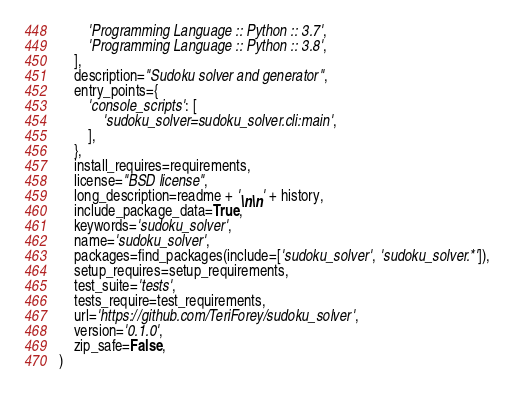<code> <loc_0><loc_0><loc_500><loc_500><_Python_>        'Programming Language :: Python :: 3.7',
        'Programming Language :: Python :: 3.8',
    ],
    description="Sudoku solver and generator",
    entry_points={
        'console_scripts': [
            'sudoku_solver=sudoku_solver.cli:main',
        ],
    },
    install_requires=requirements,
    license="BSD license",
    long_description=readme + '\n\n' + history,
    include_package_data=True,
    keywords='sudoku_solver',
    name='sudoku_solver',
    packages=find_packages(include=['sudoku_solver', 'sudoku_solver.*']),
    setup_requires=setup_requirements,
    test_suite='tests',
    tests_require=test_requirements,
    url='https://github.com/TeriForey/sudoku_solver',
    version='0.1.0',
    zip_safe=False,
)
</code> 